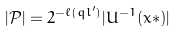<formula> <loc_0><loc_0><loc_500><loc_500>| \mathcal { P } | = 2 ^ { - \ell ( q { l } ^ { \prime } ) } | U ^ { - 1 } ( x * ) |</formula> 